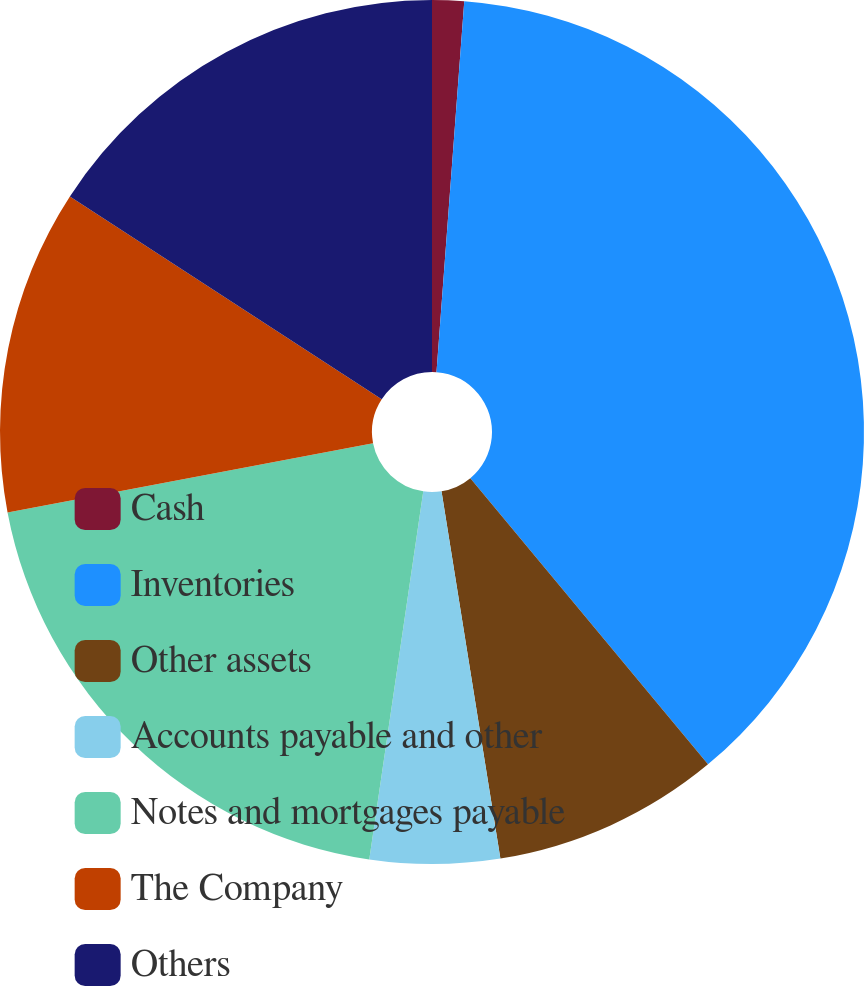<chart> <loc_0><loc_0><loc_500><loc_500><pie_chart><fcel>Cash<fcel>Inventories<fcel>Other assets<fcel>Accounts payable and other<fcel>Notes and mortgages payable<fcel>The Company<fcel>Others<nl><fcel>1.19%<fcel>37.78%<fcel>8.5%<fcel>4.85%<fcel>19.7%<fcel>12.16%<fcel>15.82%<nl></chart> 